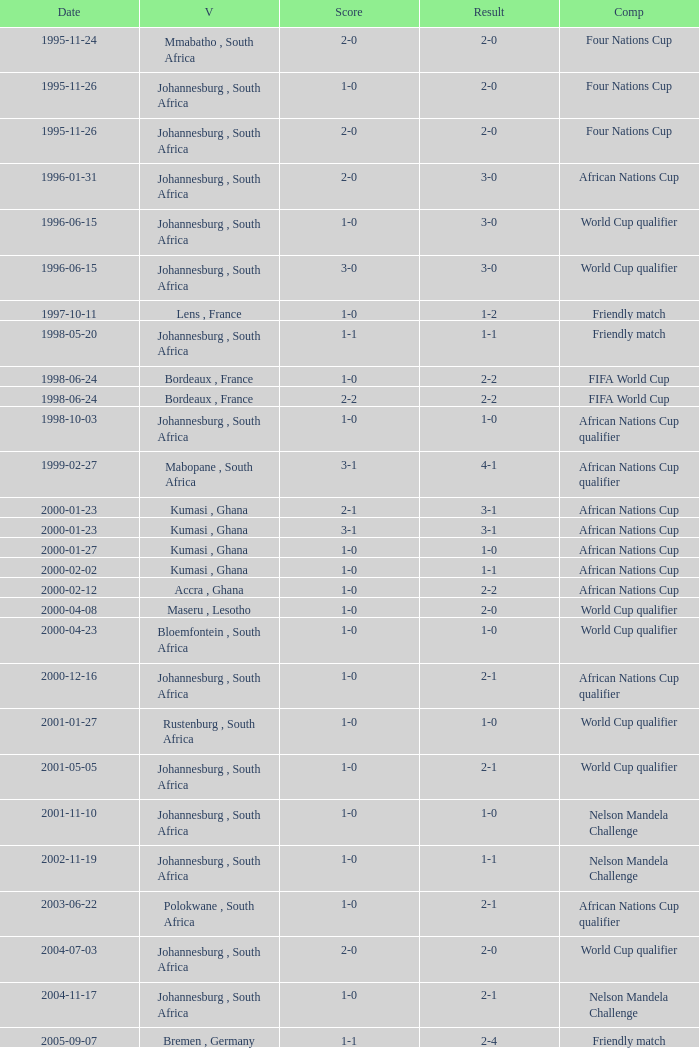What is the Date of the Fifa World Cup with a Score of 1-0? 1998-06-24. 